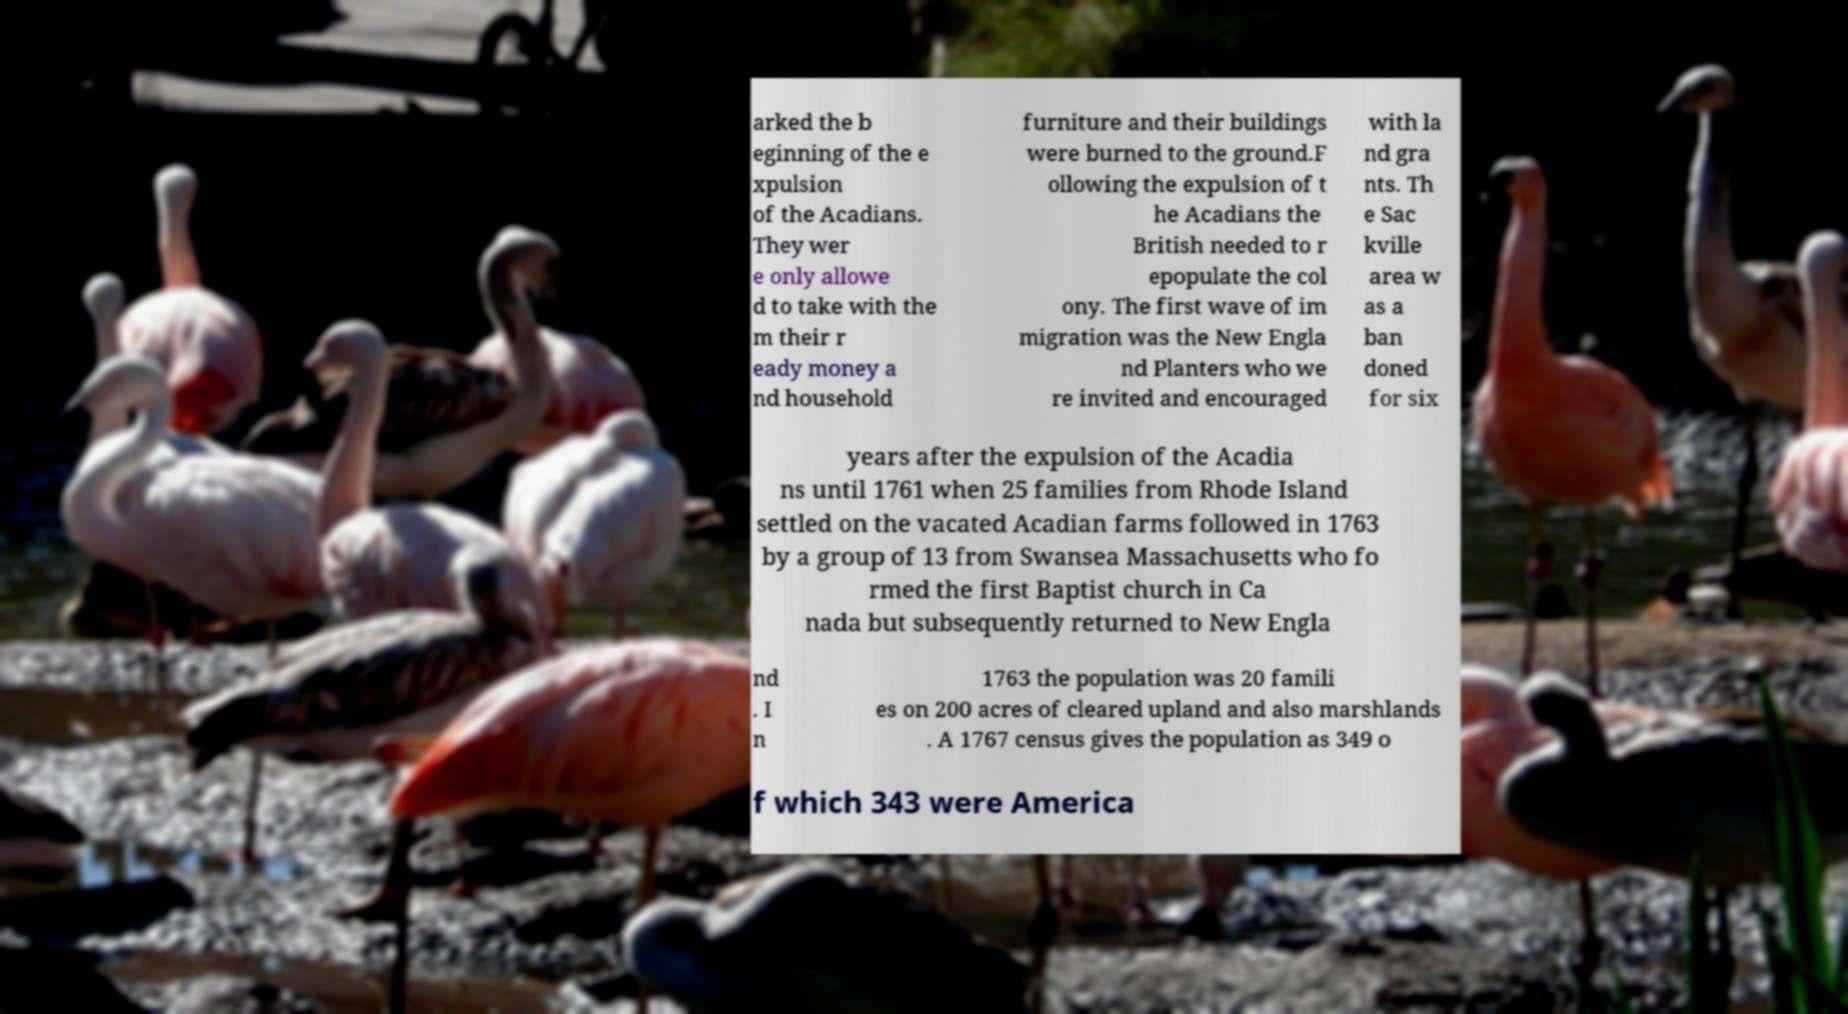Could you extract and type out the text from this image? arked the b eginning of the e xpulsion of the Acadians. They wer e only allowe d to take with the m their r eady money a nd household furniture and their buildings were burned to the ground.F ollowing the expulsion of t he Acadians the British needed to r epopulate the col ony. The first wave of im migration was the New Engla nd Planters who we re invited and encouraged with la nd gra nts. Th e Sac kville area w as a ban doned for six years after the expulsion of the Acadia ns until 1761 when 25 families from Rhode Island settled on the vacated Acadian farms followed in 1763 by a group of 13 from Swansea Massachusetts who fo rmed the first Baptist church in Ca nada but subsequently returned to New Engla nd . I n 1763 the population was 20 famili es on 200 acres of cleared upland and also marshlands . A 1767 census gives the population as 349 o f which 343 were America 